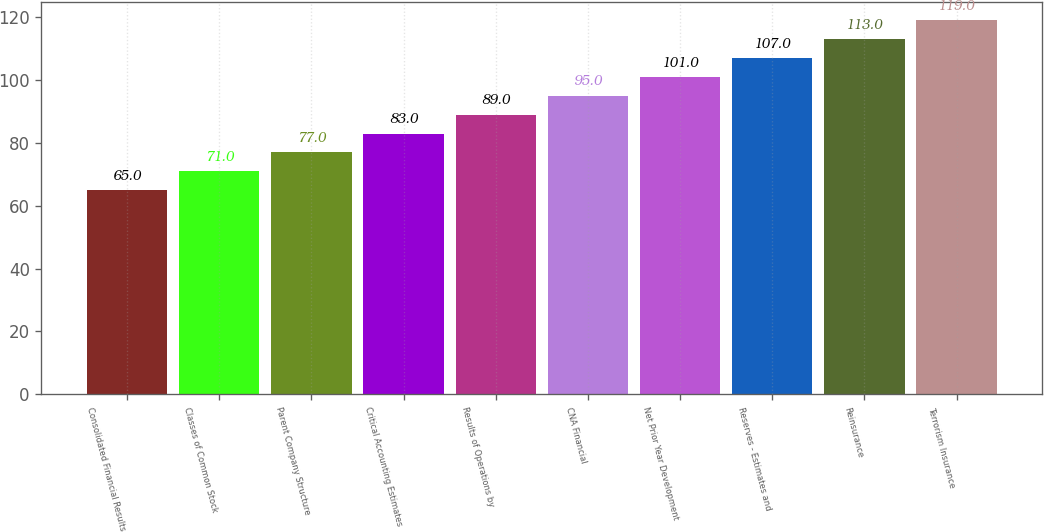Convert chart. <chart><loc_0><loc_0><loc_500><loc_500><bar_chart><fcel>Consolidated Financial Results<fcel>Classes of Common Stock<fcel>Parent Company Structure<fcel>Critical Accounting Estimates<fcel>Results of Operations by<fcel>CNA Financial<fcel>Net Prior Year Development<fcel>Reserves - Estimates and<fcel>Reinsurance<fcel>Terrorism Insurance<nl><fcel>65<fcel>71<fcel>77<fcel>83<fcel>89<fcel>95<fcel>101<fcel>107<fcel>113<fcel>119<nl></chart> 